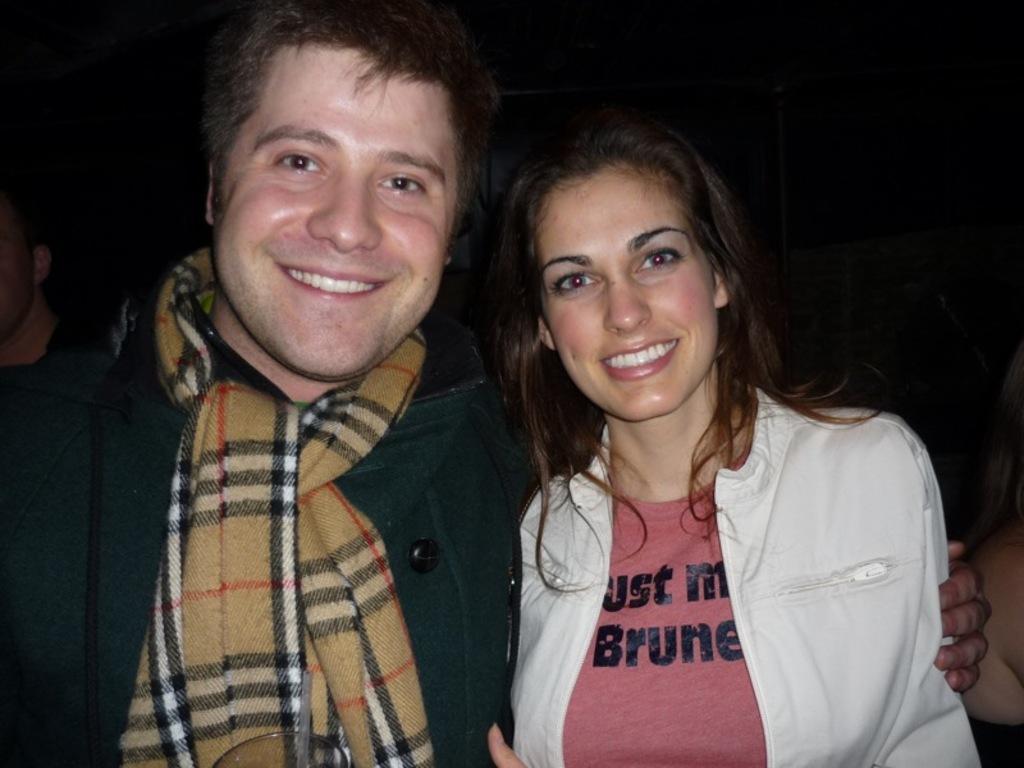How would you summarize this image in a sentence or two? In this image in the foreground there is one man and one woman and they are smiling, in the background there are some persons. 